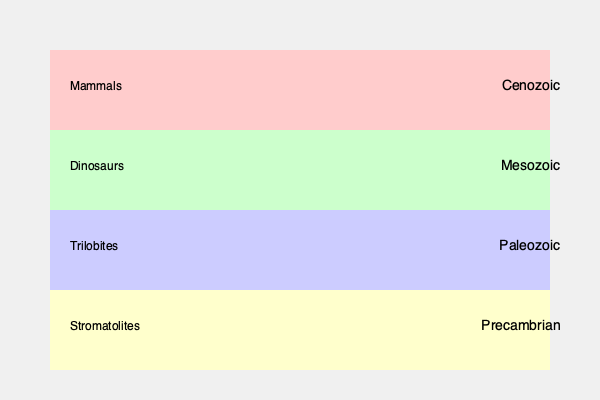In the geological timeline shown, which era is associated with the dominance of dinosaurs, and what is the correct order of the eras from most recent to oldest? To answer this question, let's analyze the geological timeline from top to bottom:

1. The topmost layer (pink) represents the Cenozoic era, which is the most recent. This era is associated with the dominance of mammals.

2. The second layer (light green) represents the Mesozoic era. This is the era associated with the dominance of dinosaurs, as indicated by the label.

3. The third layer (light blue) represents the Paleozoic era, which is known for the presence of trilobites among other organisms.

4. The bottom layer (light yellow) represents the Precambrian, the oldest era, characterized by simple life forms such as stromatolites.

The correct order of these eras from most recent to oldest is:
1. Cenozoic
2. Mesozoic
3. Paleozoic
4. Precambrian

Therefore, the era associated with the dominance of dinosaurs is the Mesozoic, and the correct order of eras from most recent to oldest is Cenozoic, Mesozoic, Paleozoic, Precambrian.
Answer: Mesozoic; Cenozoic, Mesozoic, Paleozoic, Precambrian 